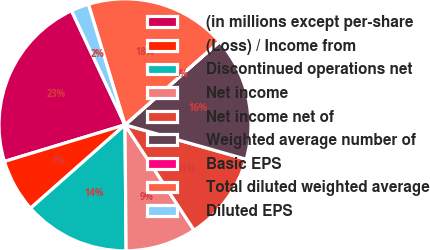<chart> <loc_0><loc_0><loc_500><loc_500><pie_chart><fcel>(in millions except per-share<fcel>(Loss) / Income from<fcel>Discontinued operations net<fcel>Net income<fcel>Net income net of<fcel>Weighted average number of<fcel>Basic EPS<fcel>Total diluted weighted average<fcel>Diluted EPS<nl><fcel>22.72%<fcel>6.82%<fcel>13.63%<fcel>9.09%<fcel>11.36%<fcel>15.91%<fcel>0.01%<fcel>18.18%<fcel>2.28%<nl></chart> 